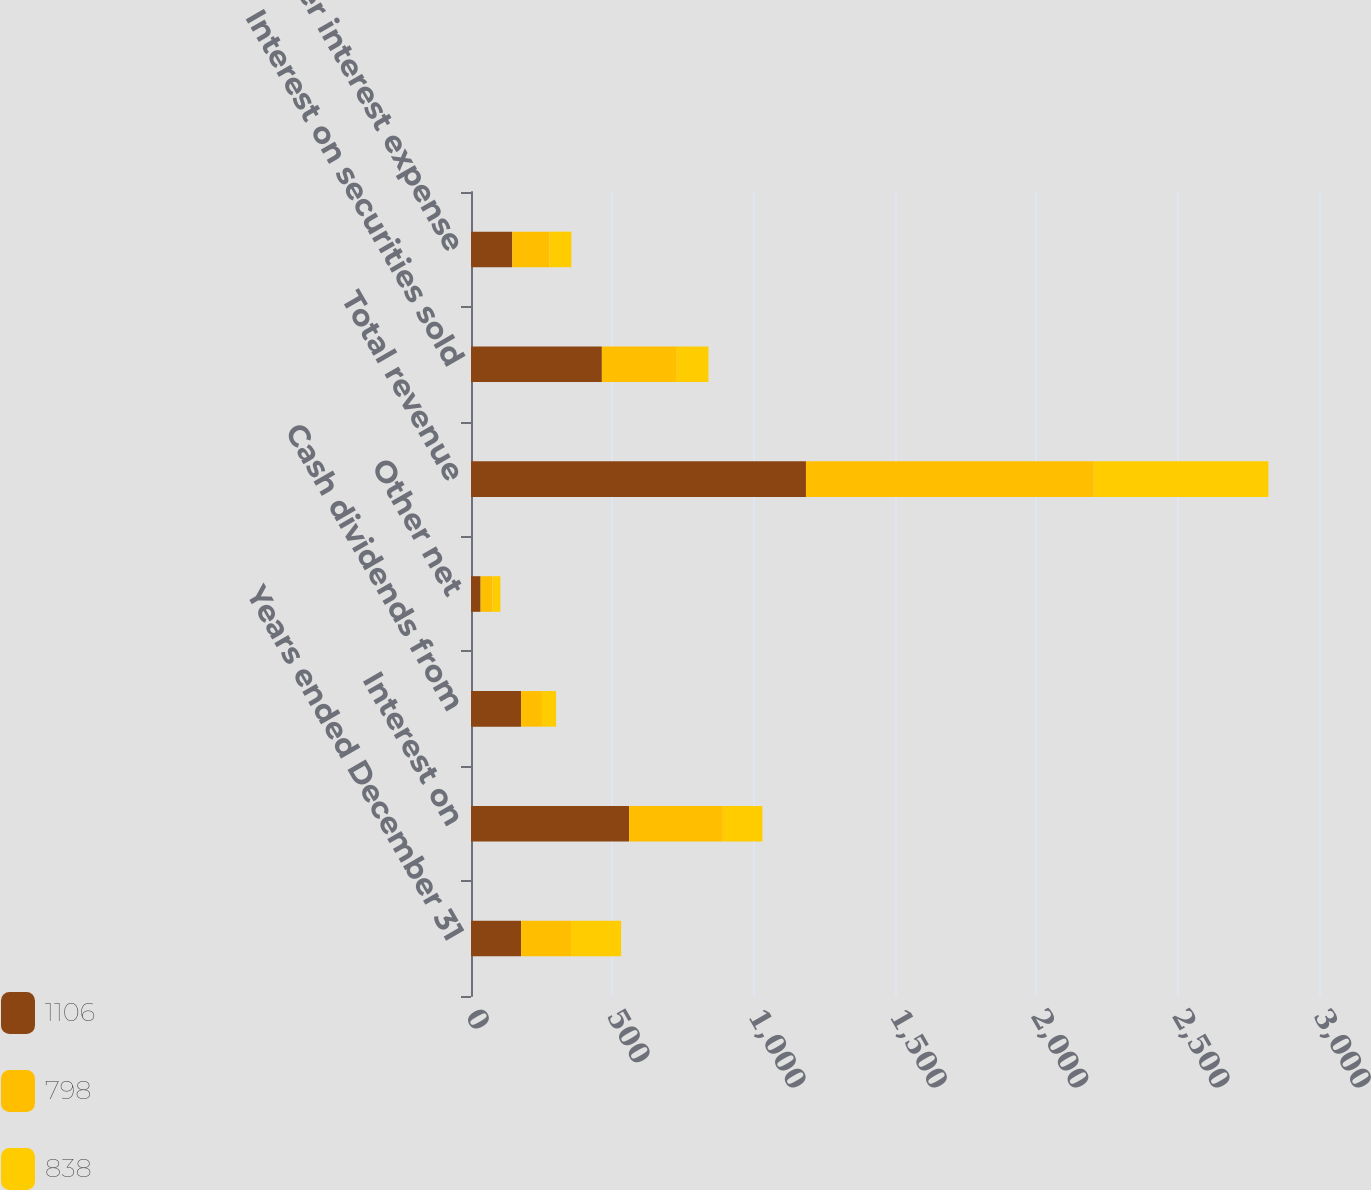Convert chart to OTSL. <chart><loc_0><loc_0><loc_500><loc_500><stacked_bar_chart><ecel><fcel>Years ended December 31<fcel>Interest on<fcel>Cash dividends from<fcel>Other net<fcel>Total revenue<fcel>Interest on securities sold<fcel>Other interest expense<nl><fcel>1106<fcel>177<fcel>559<fcel>177<fcel>34<fcel>1185<fcel>463<fcel>146<nl><fcel>798<fcel>177<fcel>332<fcel>74<fcel>42<fcel>1018<fcel>265<fcel>131<nl><fcel>838<fcel>177<fcel>140<fcel>50<fcel>28<fcel>618<fcel>112<fcel>78<nl></chart> 